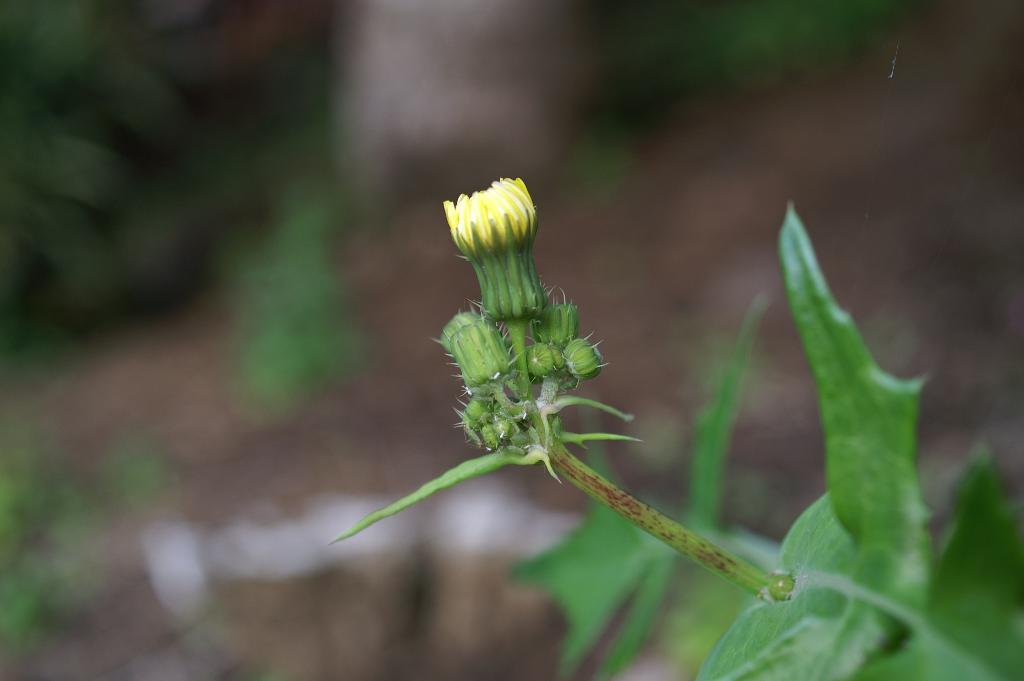What type of plant parts can be seen in the image? There are buds, stems, and leaves in the image. Can you describe the growth stage of the plants in the image? The presence of buds suggests that the plants are in an early stage of growth. What is the relationship between the different plant parts in the image? The buds, stems, and leaves are all connected and part of the same plant. How many children are playing with the stew in the image? There are no children or stew present in the image; it features plant parts such as buds, stems, and leaves. What type of finger can be seen interacting with the leaves in the image? There are no fingers present in the image; it only features plant parts. 